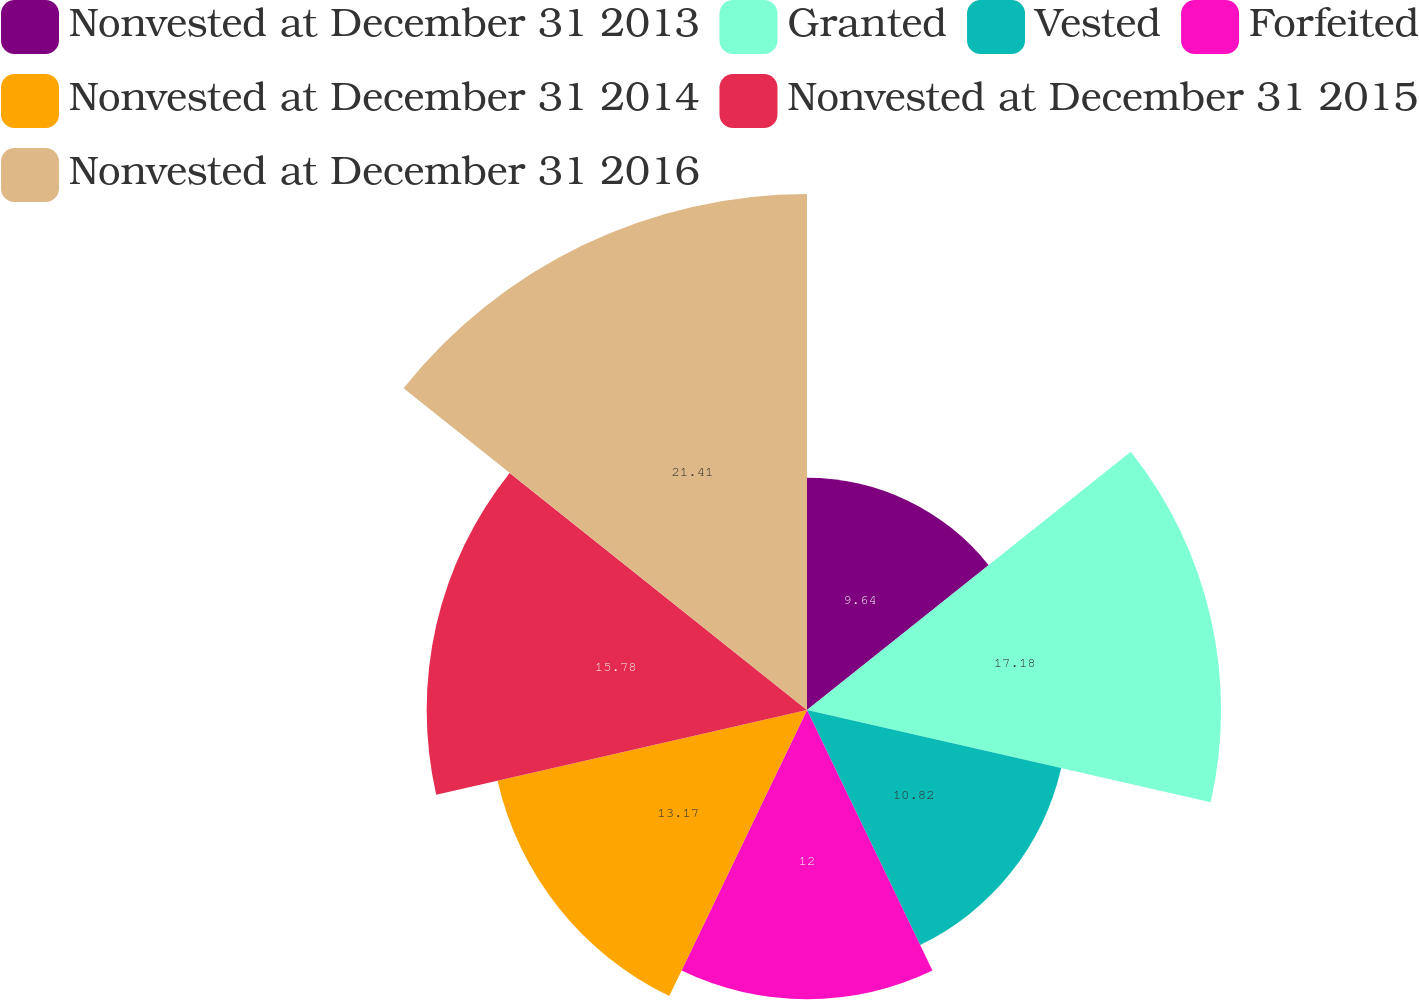Convert chart. <chart><loc_0><loc_0><loc_500><loc_500><pie_chart><fcel>Nonvested at December 31 2013<fcel>Granted<fcel>Vested<fcel>Forfeited<fcel>Nonvested at December 31 2014<fcel>Nonvested at December 31 2015<fcel>Nonvested at December 31 2016<nl><fcel>9.64%<fcel>17.18%<fcel>10.82%<fcel>12.0%<fcel>13.17%<fcel>15.78%<fcel>21.41%<nl></chart> 